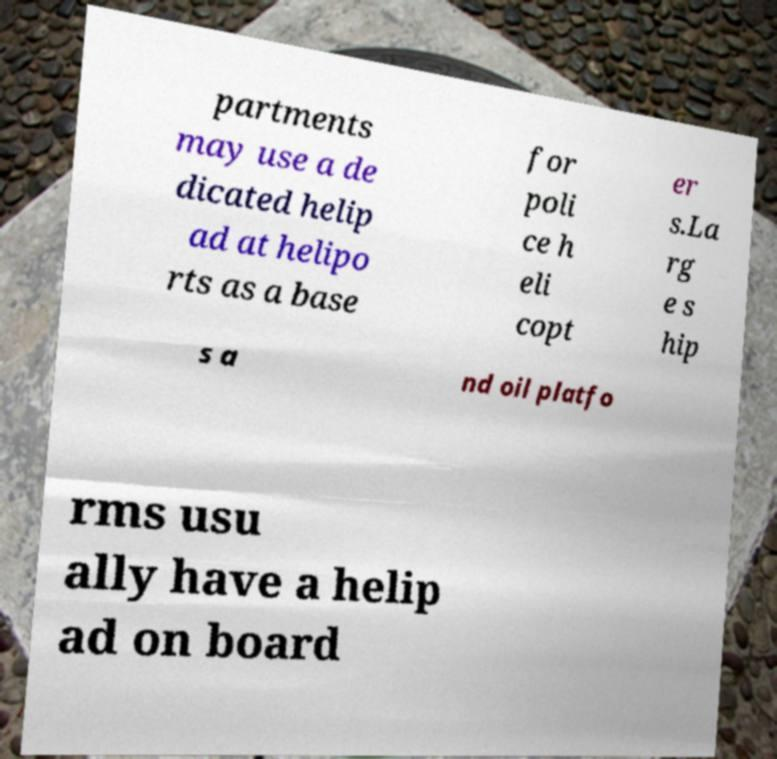Can you accurately transcribe the text from the provided image for me? partments may use a de dicated helip ad at helipo rts as a base for poli ce h eli copt er s.La rg e s hip s a nd oil platfo rms usu ally have a helip ad on board 